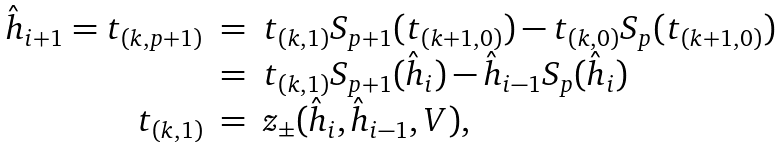Convert formula to latex. <formula><loc_0><loc_0><loc_500><loc_500>\begin{array} { r c l } \hat { h } _ { i + 1 } = t _ { ( k , p + 1 ) } & = & t _ { ( k , 1 ) } S _ { p + 1 } ( t _ { ( k + 1 , 0 ) } ) - t _ { ( k , 0 ) } S _ { p } ( t _ { ( k + 1 , 0 ) } ) \\ & = & t _ { ( k , 1 ) } S _ { p + 1 } ( \hat { h } _ { i } ) - \hat { h } _ { i - 1 } S _ { p } ( \hat { h } _ { i } ) \\ t _ { ( k , 1 ) } & = & z _ { \pm } ( \hat { h } _ { i } , \hat { h } _ { i - 1 } , V ) , \end{array}</formula> 